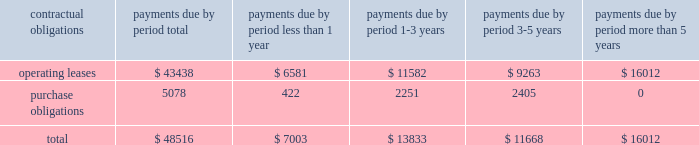Approved by the board of directors on april 21 , 2004 and expired on april 30 , 2006 .
Sources and uses in financing activities during 2005 related primarily to uses for the payment of a dividend ( $ 54.0 million ) and stock repurchase ( $ 26.7 million ) , and a source of cash from the issuance of common shares related to the exercise of employee stock options , the related tax benefit , and the employee stock purchase plan ( $ 9.7 million ) .
Cash dividends paid to shareholders were $ 162.5 million , $ 107.9 million , and $ 54.0 million during fiscal years 2007 , 2006 , and 2005 , respectively .
We believe that our existing cash balances and cash flow from operations will be sufficient to meet our projected capital expenditures , working capital and other cash requirements at least through the end of fiscal 2010 .
Contractual obligations and commercial commitments future commitments of garmin , as of december 29 , 2007 , aggregated by type of contractual obligation .
Operating leases describes lease obligations associated with garmin facilities located in the u.s. , taiwan , the u.k. , and canada .
Purchase obligations are the aggregate of those purchase orders that were outstanding on december 29 , 2007 ; these obligations are created and then paid off within 3 months during the normal course of our manufacturing business .
Off-balance sheet arrangements we do not have any off-balance sheet arrangements .
Item 7a .
Quantitative and qualitative disclosures about market risk market sensitivity we have market risk primarily in connection with the pricing of our products and services and the purchase of raw materials .
Product pricing and raw materials costs are both significantly influenced by semiconductor market conditions .
Historically , during cyclical industry downturns , we have been able to offset pricing declines for our products through a combination of improved product mix and success in obtaining price reductions in raw materials costs .
Inflation we do not believe that inflation has had a material effect on our business , financial condition or results of operations .
If our costs were to become subject to significant inflationary pressures , we may not be able to fully offset such higher costs through price increases .
Our inability or failure to do so could adversely affect our business , financial condition and results of operations .
Foreign currency exchange rate risk the operation of garmin 2019s subsidiaries in international markets results in exposure to movements in currency exchange rates .
We generally have not been significantly affected by foreign exchange fluctuations .
What percentage of total contractual obligations and commercial commitments future commitments of garmin , as of december 29 , 2007 are due to operating leases? 
Computations: (43438 / 48516)
Answer: 0.89533. 